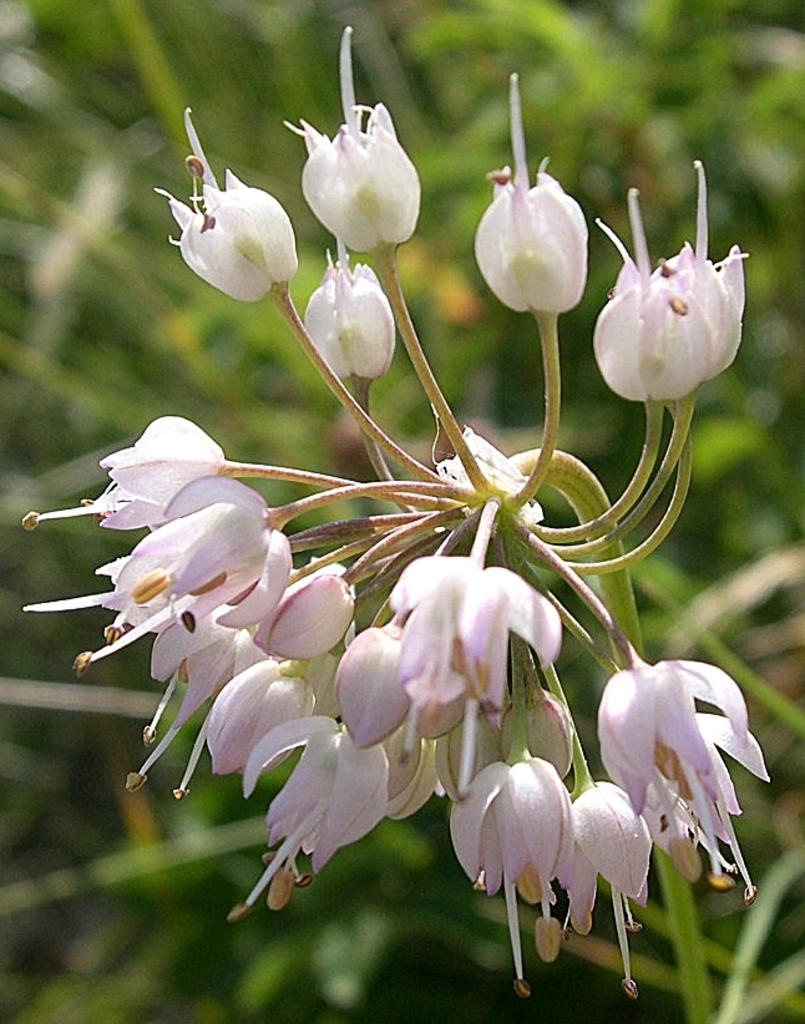What type of flora is present in the image? There are flowers with stems in the image. Are there any other plants visible in the image? There may be plants beside the flowers. Can you describe the background of the image? The background of the image is slightly blurred. What is the annual income of the flowers in the image? There is no information about the income of the flowers in the image, as flowers do not have an income. 